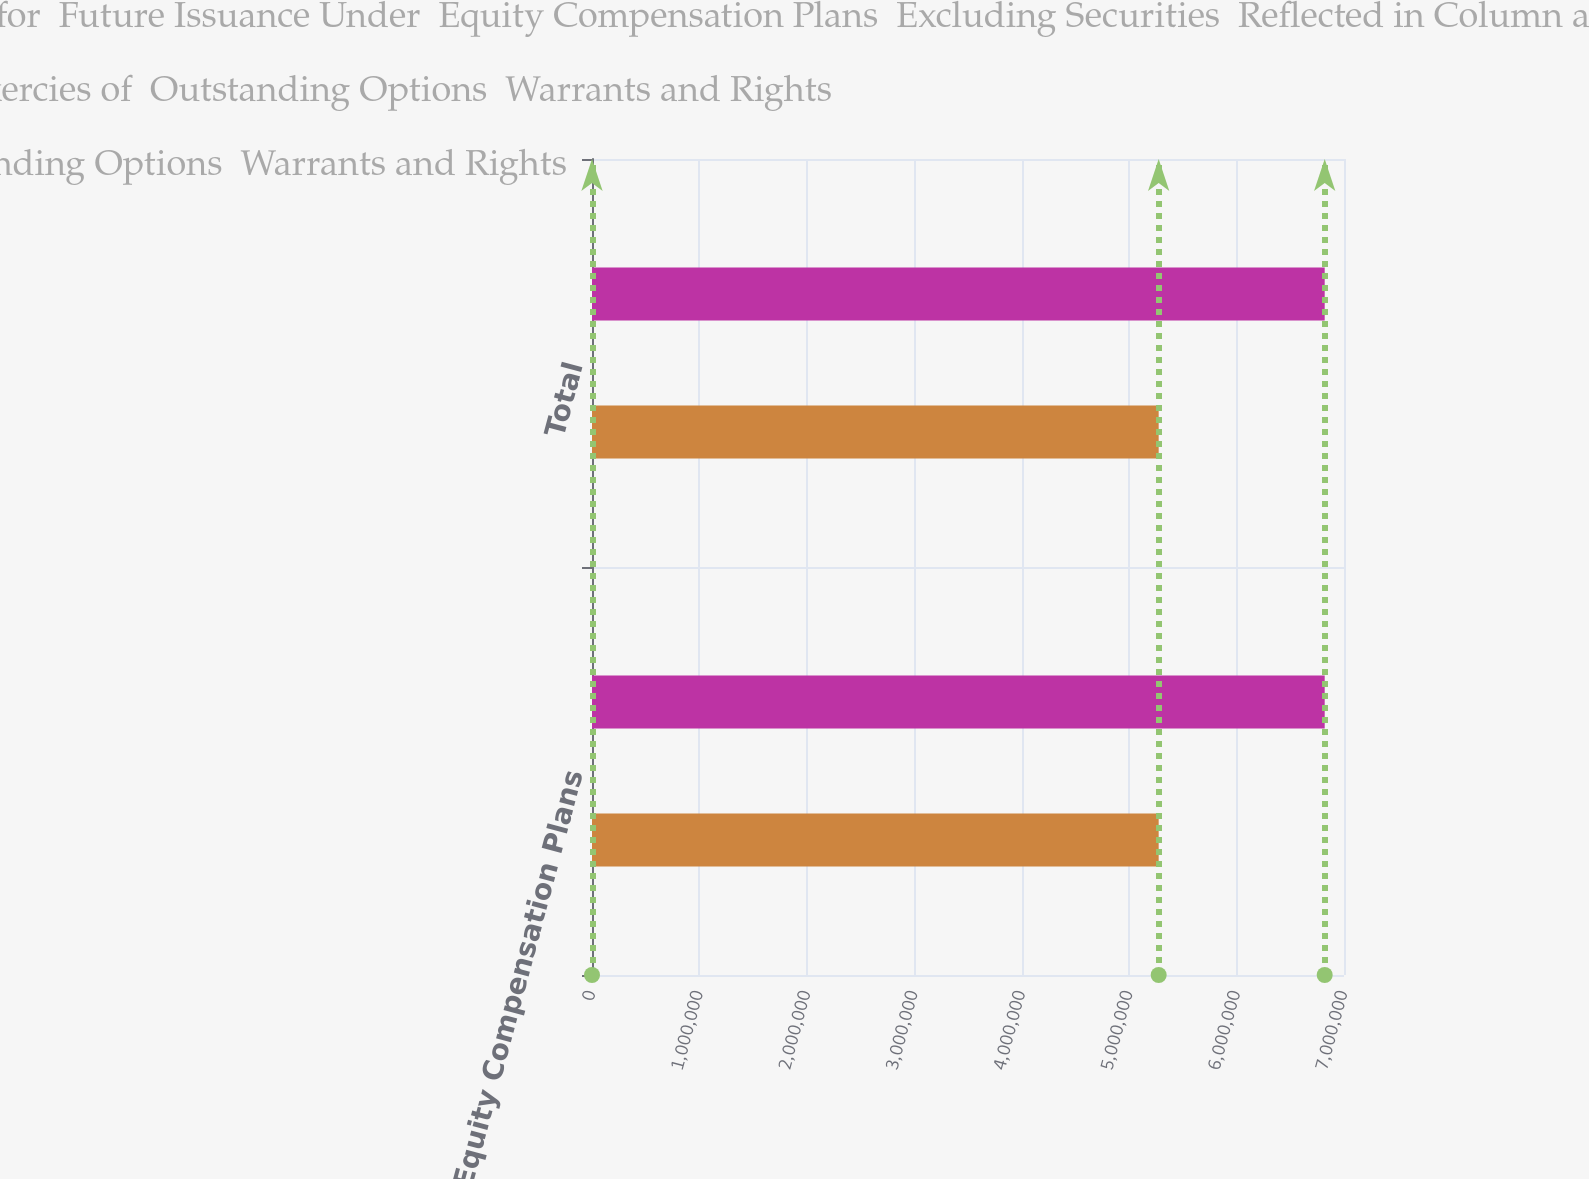Convert chart to OTSL. <chart><loc_0><loc_0><loc_500><loc_500><stacked_bar_chart><ecel><fcel>Equity Compensation Plans<fcel>Total<nl><fcel>Number of Securities  Remaining Available for  Future Issuance Under  Equity Compensation Plans  Excluding Securities  Reflected in Column a<fcel>6.82029e+06<fcel>6.82029e+06<nl><fcel>Number of Securities  to be Issued Upon  Exercies of  Outstanding Options  Warrants and Rights<fcel>45.01<fcel>45.01<nl><fcel>Weighted Average  Exercise Price of  Outstanding Options  Warrants and Rights<fcel>5.2749e+06<fcel>5.2749e+06<nl></chart> 